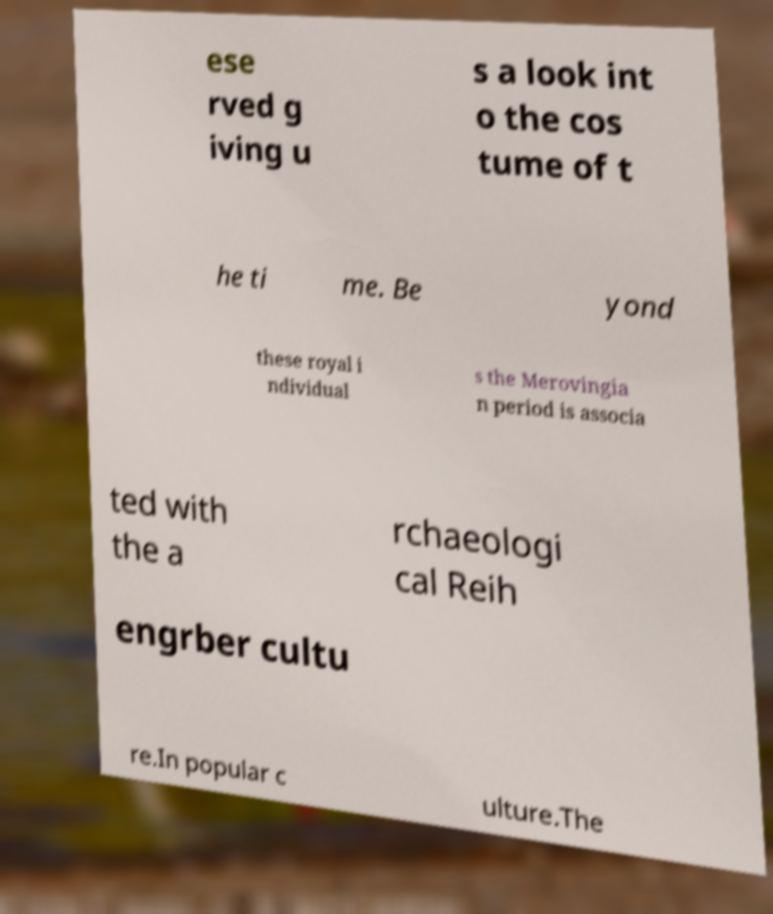I need the written content from this picture converted into text. Can you do that? ese rved g iving u s a look int o the cos tume of t he ti me. Be yond these royal i ndividual s the Merovingia n period is associa ted with the a rchaeologi cal Reih engrber cultu re.In popular c ulture.The 